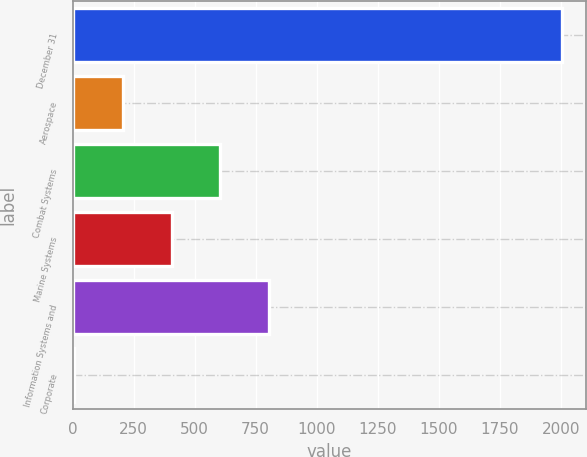<chart> <loc_0><loc_0><loc_500><loc_500><bar_chart><fcel>December 31<fcel>Aerospace<fcel>Combat Systems<fcel>Marine Systems<fcel>Information Systems and<fcel>Corporate<nl><fcel>2004<fcel>205.8<fcel>605.4<fcel>405.6<fcel>805.2<fcel>6<nl></chart> 